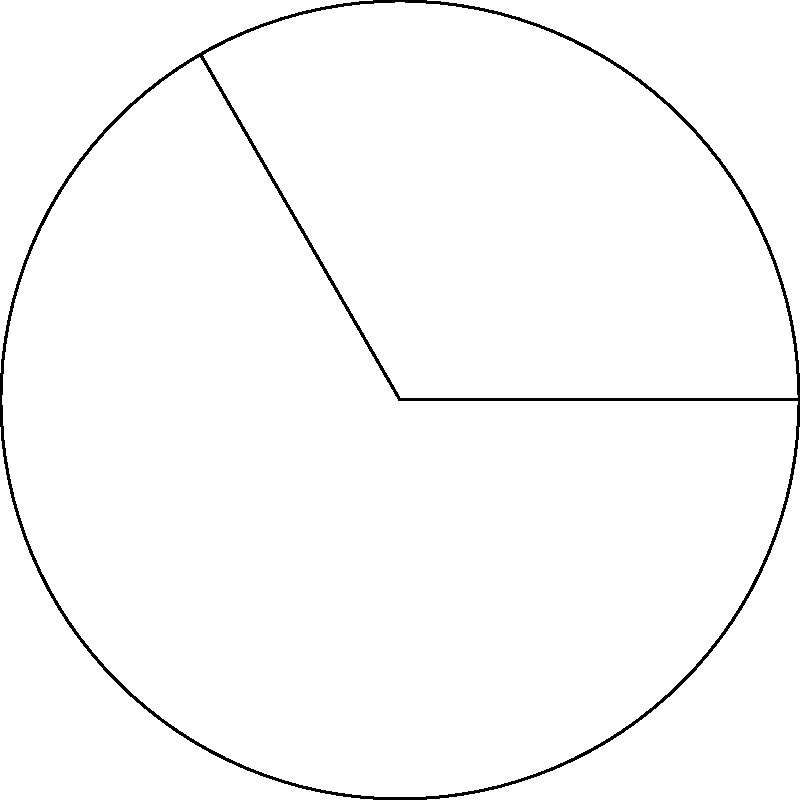In a circular biotech growth chamber, a sector is used for a specialized experiment. The chamber has a radius of 3 cm, and the sector spans a central angle of 120°. Calculate the area of this experimental sector and express it as a fraction of the total chamber area. How might this ratio inform the design of multi-compartment growth chambers for different cell lines? Let's approach this step-by-step:

1) The area of a circular sector is given by the formula:
   $$A_{sector} = \frac{1}{2}r^2\theta$$
   where $r$ is the radius and $\theta$ is the central angle in radians.

2) We need to convert 120° to radians:
   $$\theta = 120° \cdot \frac{\pi}{180°} = \frac{2\pi}{3} \text{ radians}$$

3) Now we can calculate the area of the sector:
   $$A_{sector} = \frac{1}{2} \cdot 3^2 \cdot \frac{2\pi}{3} = 3\pi \text{ cm}^2$$

4) The total area of the circular chamber is:
   $$A_{total} = \pi r^2 = \pi \cdot 3^2 = 9\pi \text{ cm}^2$$

5) The ratio of the sector area to the total area is:
   $$\frac{A_{sector}}{A_{total}} = \frac{3\pi}{9\pi} = \frac{1}{3}$$

6) This ratio indicates that the experimental sector occupies one-third of the total chamber area.

7) In terms of multi-compartment growth chamber design, this ratio suggests that three equal experiments could be conducted simultaneously in a single circular chamber. This efficient use of space could be valuable when working with different cell lines that require identical environmental conditions but need to be kept separate.

8) The flexibility of adjusting the central angle allows for customization of compartment sizes based on the specific needs of different cell lines or experimental protocols.
Answer: $\frac{1}{3}$ of the total area 